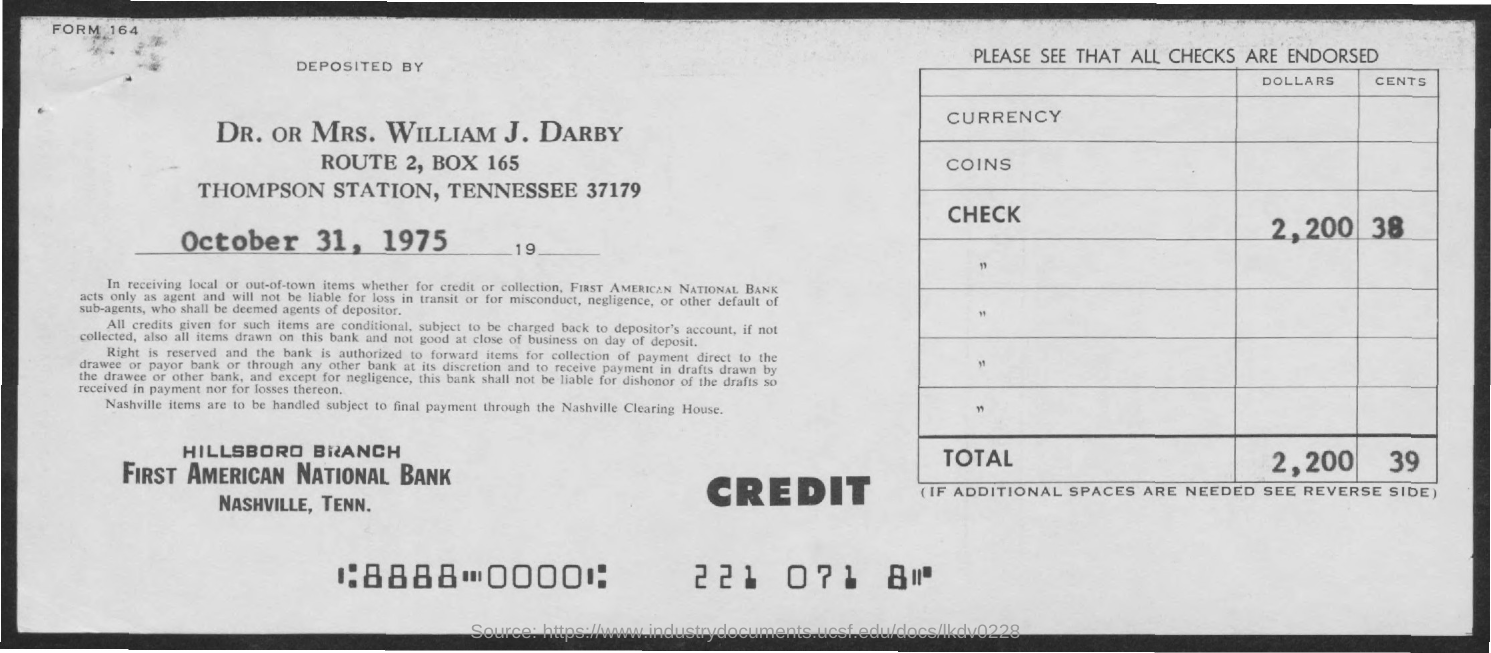What is the date mentioned in this document ?
Keep it short and to the point. October 31, 1975. How much Total Amount ?
Give a very brief answer. 2,200 39. 